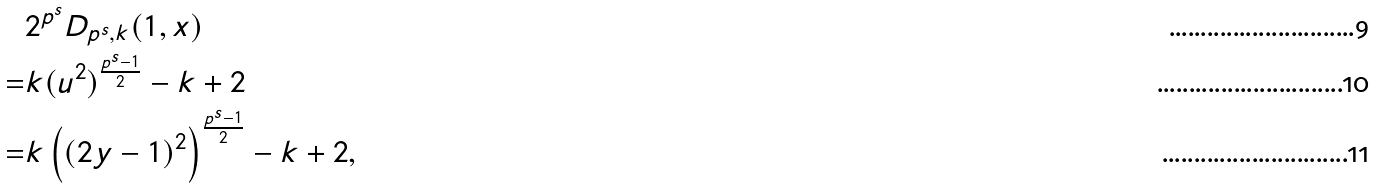<formula> <loc_0><loc_0><loc_500><loc_500>& 2 ^ { p ^ { s } } D _ { p ^ { s } , k } ( 1 , x ) \\ = & k ( u ^ { 2 } ) ^ { \frac { p ^ { s } - 1 } { 2 } } - k + 2 \\ = & k \left ( ( 2 y - 1 ) ^ { 2 } \right ) ^ { \frac { p ^ { s } - 1 } { 2 } } - k + 2 ,</formula> 